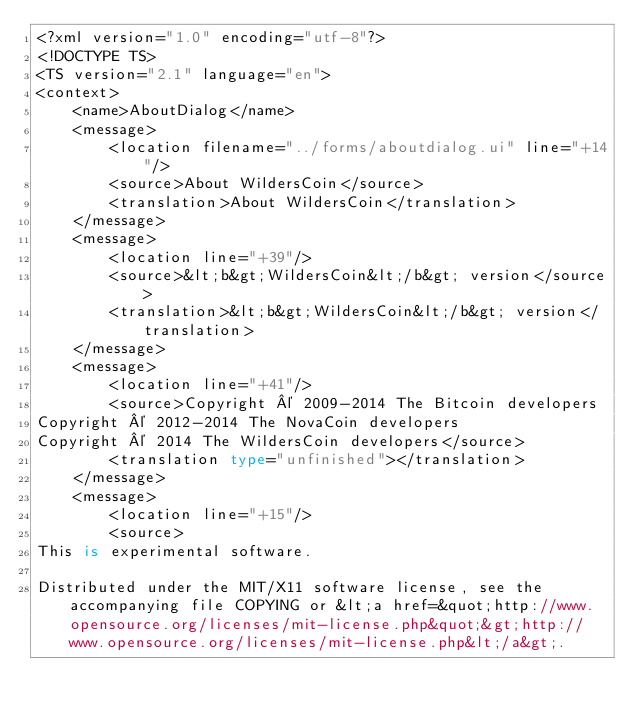Convert code to text. <code><loc_0><loc_0><loc_500><loc_500><_TypeScript_><?xml version="1.0" encoding="utf-8"?>
<!DOCTYPE TS>
<TS version="2.1" language="en">
<context>
    <name>AboutDialog</name>
    <message>
        <location filename="../forms/aboutdialog.ui" line="+14"/>
        <source>About WildersCoin</source>
        <translation>About WildersCoin</translation>
    </message>
    <message>
        <location line="+39"/>
        <source>&lt;b&gt;WildersCoin&lt;/b&gt; version</source>
        <translation>&lt;b&gt;WildersCoin&lt;/b&gt; version</translation>
    </message>
    <message>
        <location line="+41"/>
        <source>Copyright © 2009-2014 The Bitcoin developers
Copyright © 2012-2014 The NovaCoin developers
Copyright © 2014 The WildersCoin developers</source>
        <translation type="unfinished"></translation>
    </message>
    <message>
        <location line="+15"/>
        <source>
This is experimental software.

Distributed under the MIT/X11 software license, see the accompanying file COPYING or &lt;a href=&quot;http://www.opensource.org/licenses/mit-license.php&quot;&gt;http://www.opensource.org/licenses/mit-license.php&lt;/a&gt;.
</code> 